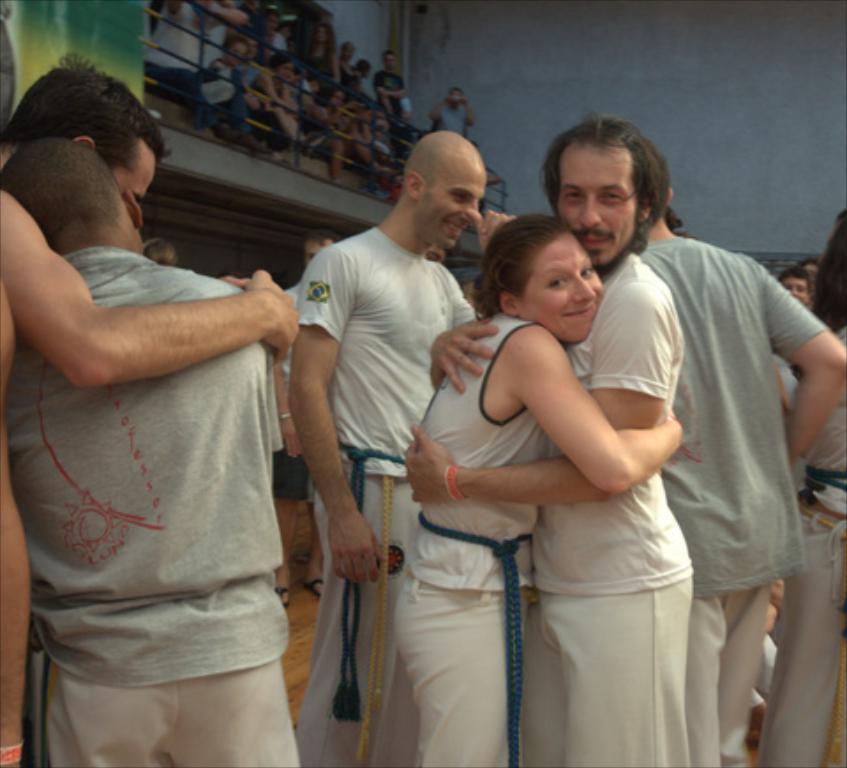Could you give a brief overview of what you see in this image? In this image we can see a few people, some of them are sitting on the seats, there is a railing, there is a banner, we can see a man, and woman are hugging, also we can see the wall, and two men are hugging. 